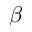Convert formula to latex. <formula><loc_0><loc_0><loc_500><loc_500>\beta</formula> 